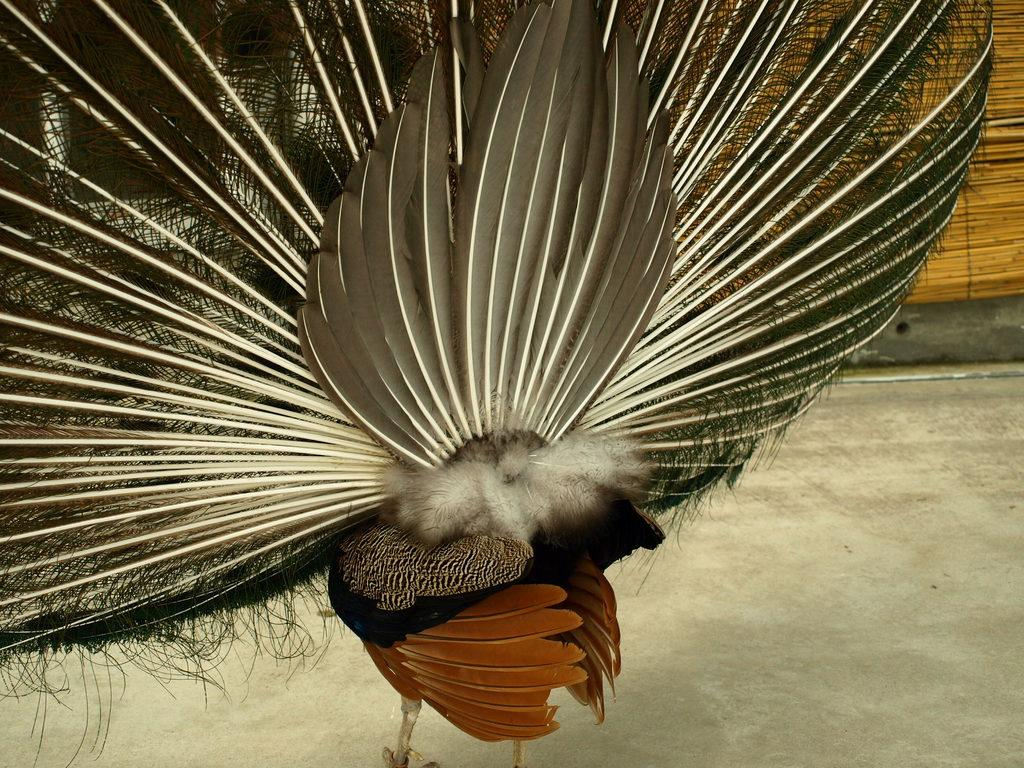What type of animal is in the image? There is a peacock in the image. Where is the peacock located in the image? The peacock is standing on the floor. What part of the peacock is visible in the image? The image shows the peacock from the back side. What type of flesh can be seen on the peacock in the image? There is no flesh visible on the peacock in the image, as peacocks are birds and do not have visible flesh. 